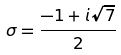<formula> <loc_0><loc_0><loc_500><loc_500>\sigma = \frac { - 1 + i \sqrt { 7 } } { 2 }</formula> 